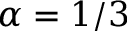<formula> <loc_0><loc_0><loc_500><loc_500>\alpha = 1 / 3</formula> 